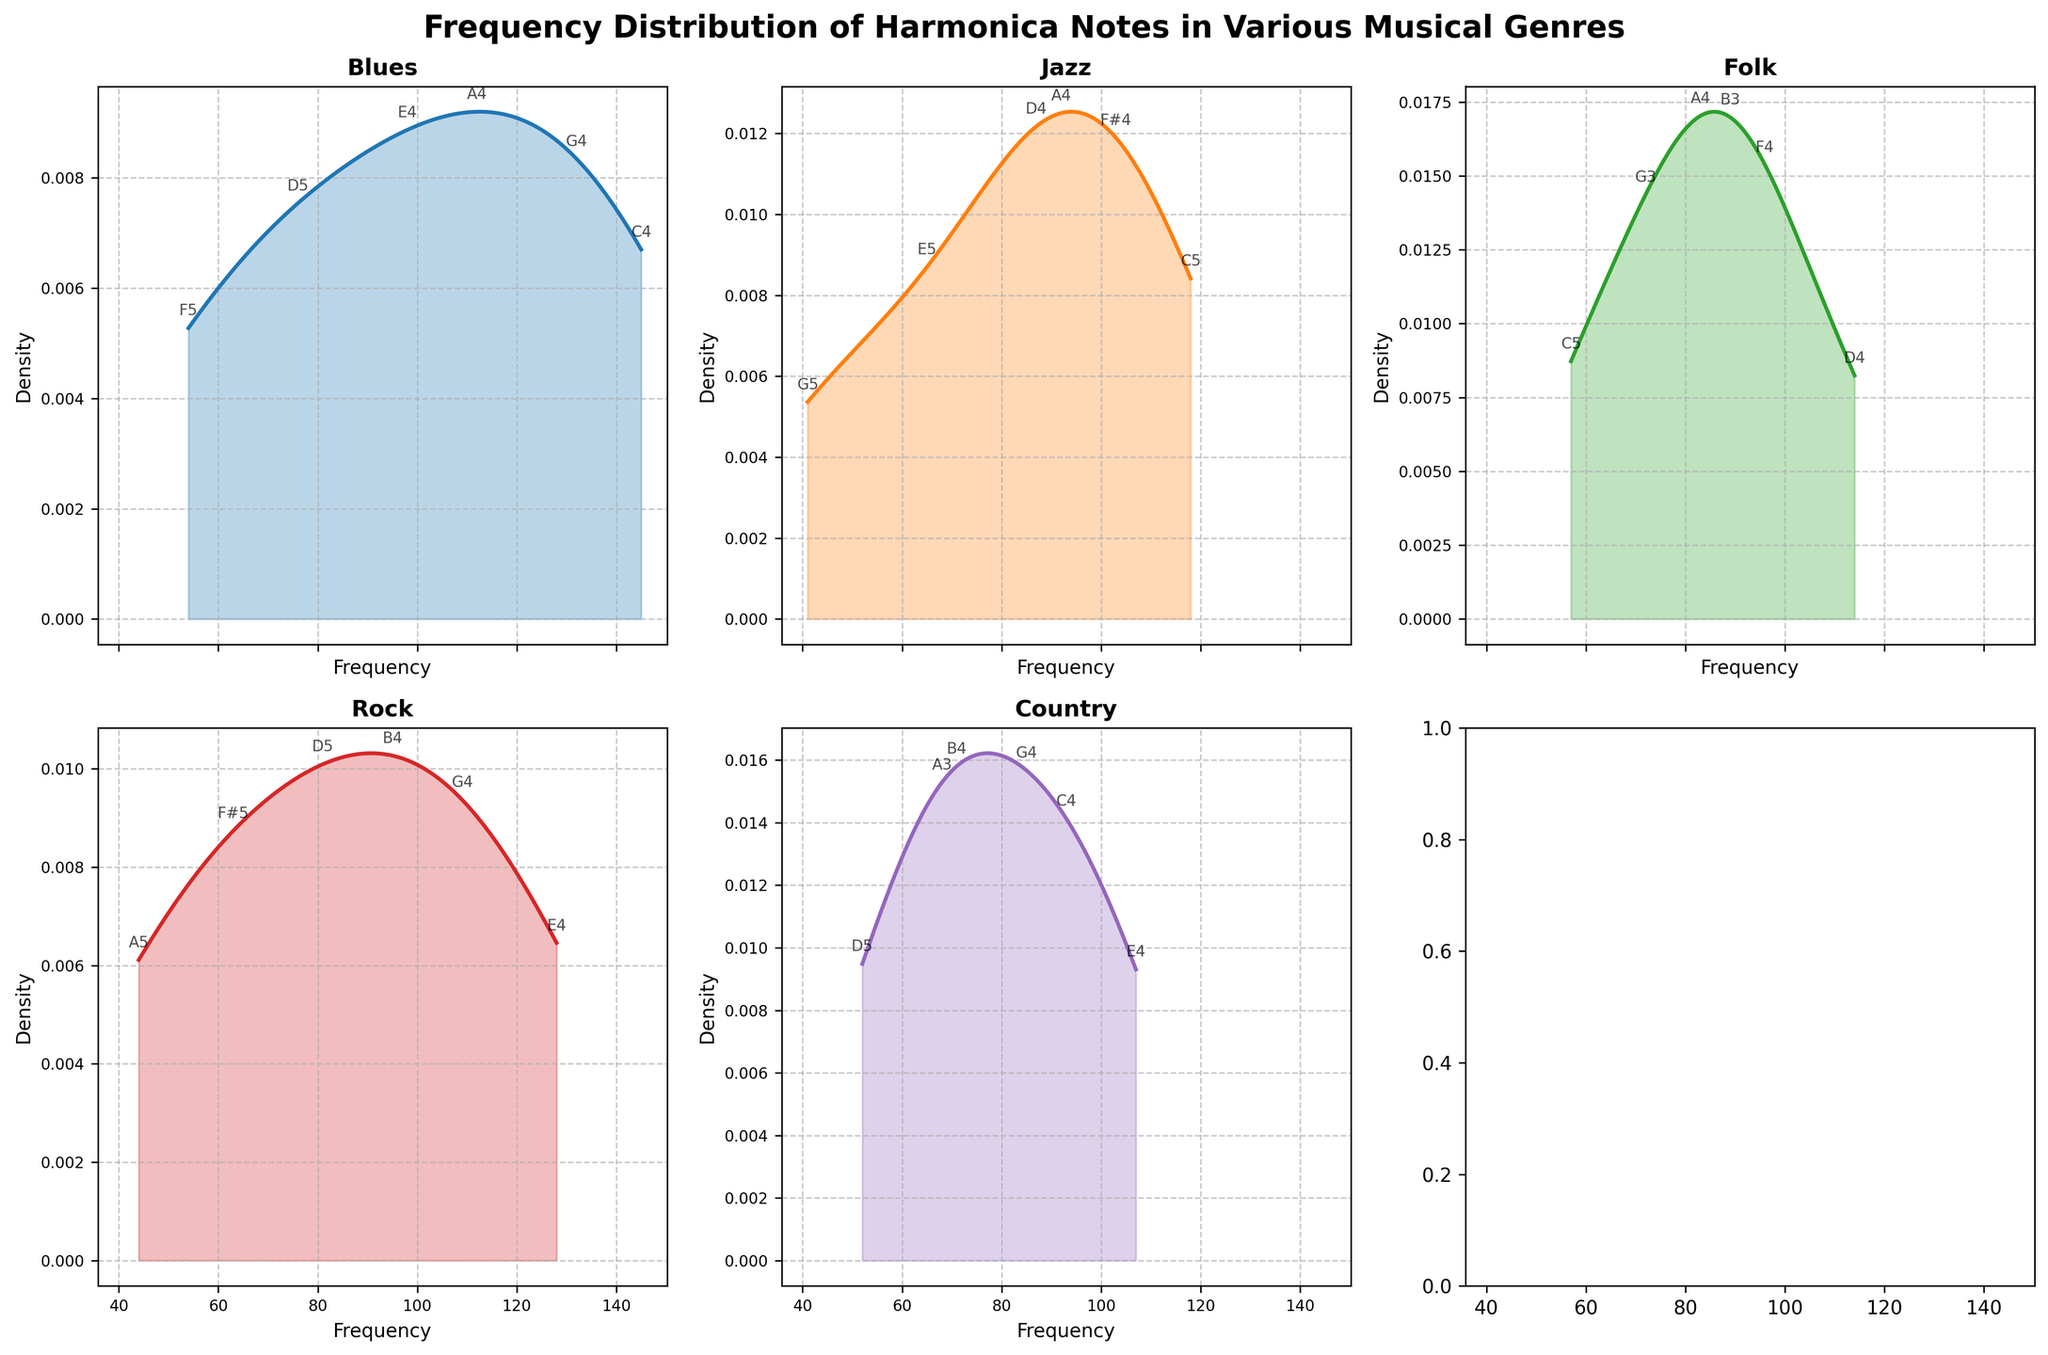Which genre shows the highest peak in the density plot? To determine which genre has the highest peak in the density plot, look at the figure and identify which graph has the highest y-axis value at its peak.
Answer: Blues What is the main title of the figure? The main title is displayed at the top of the figure, summarizing the content of all the subplots.
Answer: Frequency Distribution of Harmonica Notes in Various Musical Genres How many genres are represented in the subplots? Count the number of individual subplots within the figure to identify the number of genres represented.
Answer: Five Which genre has the most evenly distributed frequency of notes? Examine the density plots for each genre. The genre with the flattest or least peaked density curve shows a more even distribution of note frequencies.
Answer: Folk In the Blues genre, which note frequency is the highest peak labeled on the density plot? Look at the Blues subplot and find the annotated note at the highest peak of the density curve.
Answer: C4 Between Rock and Country, which genre has a higher peak density value? Compare the peak heights of the density curves for the Rock and Country subplots to identify which one is higher.
Answer: Rock What can be inferred about the density distribution of the note frequencies in the Jazz genre compared to Country? Look at the density plots of Jazz and Country, and note the spread and height of the peaks. Jazz is expected to be narrower and taller compared to the wider and possibly shorter peak of Country.
Answer: Jazz has a narrower, taller peak compared to Country's wider distribution Are there any genres where the distribution of note frequencies is bimodal? Check each subplot to see if there are two clear peaks in the density plot.
Answer: No Which genre shows the lowest density value at any point? Scan through each subplot to find the lowest dip in the density plots.
Answer: Jazz Among Blues, Folk, and Rock, which genre has the widest spread of note frequency distribution? Compare the ranges of the x-axes (frequency) across these genres. The one with the widest range of frequencies (most spread out) has the widest spread.
Answer: Blues 